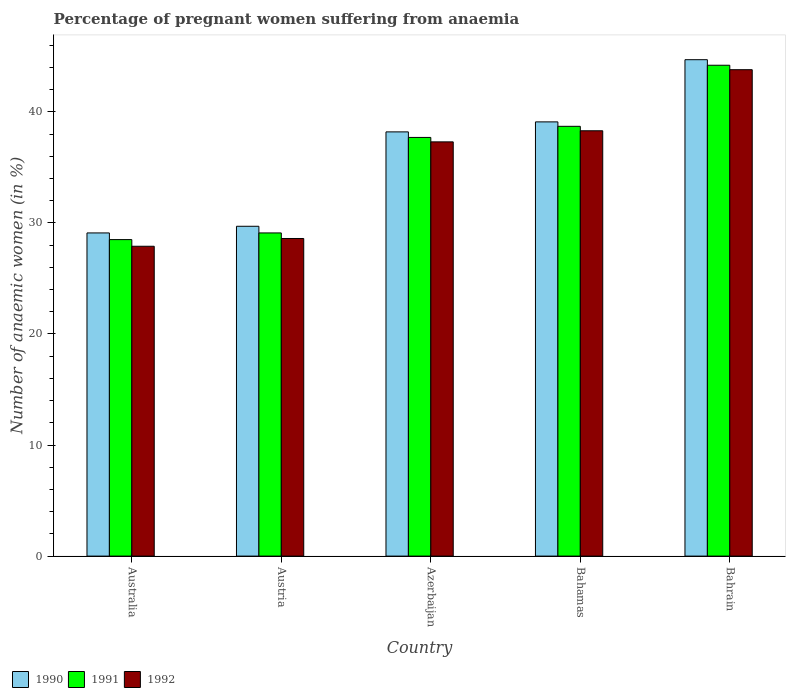How many different coloured bars are there?
Ensure brevity in your answer.  3. Are the number of bars per tick equal to the number of legend labels?
Provide a succinct answer. Yes. Are the number of bars on each tick of the X-axis equal?
Provide a short and direct response. Yes. What is the label of the 5th group of bars from the left?
Your answer should be compact. Bahrain. In how many cases, is the number of bars for a given country not equal to the number of legend labels?
Your answer should be compact. 0. What is the number of anaemic women in 1991 in Bahamas?
Your answer should be compact. 38.7. Across all countries, what is the maximum number of anaemic women in 1992?
Provide a short and direct response. 43.8. Across all countries, what is the minimum number of anaemic women in 1990?
Offer a very short reply. 29.1. In which country was the number of anaemic women in 1990 maximum?
Provide a succinct answer. Bahrain. In which country was the number of anaemic women in 1990 minimum?
Offer a very short reply. Australia. What is the total number of anaemic women in 1991 in the graph?
Provide a short and direct response. 178.2. What is the difference between the number of anaemic women in 1990 in Azerbaijan and that in Bahamas?
Offer a very short reply. -0.9. What is the average number of anaemic women in 1990 per country?
Provide a short and direct response. 36.16. What is the difference between the number of anaemic women of/in 1991 and number of anaemic women of/in 1992 in Australia?
Your answer should be compact. 0.6. In how many countries, is the number of anaemic women in 1991 greater than 28 %?
Give a very brief answer. 5. What is the ratio of the number of anaemic women in 1990 in Azerbaijan to that in Bahamas?
Make the answer very short. 0.98. Is the number of anaemic women in 1991 in Australia less than that in Bahamas?
Provide a succinct answer. Yes. What is the difference between the highest and the lowest number of anaemic women in 1991?
Give a very brief answer. 15.7. Is the sum of the number of anaemic women in 1990 in Australia and Azerbaijan greater than the maximum number of anaemic women in 1991 across all countries?
Offer a very short reply. Yes. What does the 3rd bar from the left in Australia represents?
Provide a short and direct response. 1992. Is it the case that in every country, the sum of the number of anaemic women in 1991 and number of anaemic women in 1990 is greater than the number of anaemic women in 1992?
Make the answer very short. Yes. How many bars are there?
Offer a very short reply. 15. How many countries are there in the graph?
Provide a succinct answer. 5. Where does the legend appear in the graph?
Provide a succinct answer. Bottom left. What is the title of the graph?
Keep it short and to the point. Percentage of pregnant women suffering from anaemia. What is the label or title of the X-axis?
Provide a succinct answer. Country. What is the label or title of the Y-axis?
Your answer should be compact. Number of anaemic women (in %). What is the Number of anaemic women (in %) of 1990 in Australia?
Give a very brief answer. 29.1. What is the Number of anaemic women (in %) of 1991 in Australia?
Your response must be concise. 28.5. What is the Number of anaemic women (in %) in 1992 in Australia?
Offer a terse response. 27.9. What is the Number of anaemic women (in %) of 1990 in Austria?
Ensure brevity in your answer.  29.7. What is the Number of anaemic women (in %) in 1991 in Austria?
Give a very brief answer. 29.1. What is the Number of anaemic women (in %) of 1992 in Austria?
Ensure brevity in your answer.  28.6. What is the Number of anaemic women (in %) in 1990 in Azerbaijan?
Your answer should be compact. 38.2. What is the Number of anaemic women (in %) in 1991 in Azerbaijan?
Ensure brevity in your answer.  37.7. What is the Number of anaemic women (in %) in 1992 in Azerbaijan?
Keep it short and to the point. 37.3. What is the Number of anaemic women (in %) in 1990 in Bahamas?
Your answer should be compact. 39.1. What is the Number of anaemic women (in %) of 1991 in Bahamas?
Your response must be concise. 38.7. What is the Number of anaemic women (in %) in 1992 in Bahamas?
Give a very brief answer. 38.3. What is the Number of anaemic women (in %) of 1990 in Bahrain?
Provide a succinct answer. 44.7. What is the Number of anaemic women (in %) of 1991 in Bahrain?
Your response must be concise. 44.2. What is the Number of anaemic women (in %) of 1992 in Bahrain?
Your answer should be compact. 43.8. Across all countries, what is the maximum Number of anaemic women (in %) of 1990?
Ensure brevity in your answer.  44.7. Across all countries, what is the maximum Number of anaemic women (in %) in 1991?
Your answer should be very brief. 44.2. Across all countries, what is the maximum Number of anaemic women (in %) of 1992?
Your answer should be compact. 43.8. Across all countries, what is the minimum Number of anaemic women (in %) in 1990?
Provide a short and direct response. 29.1. Across all countries, what is the minimum Number of anaemic women (in %) of 1991?
Make the answer very short. 28.5. Across all countries, what is the minimum Number of anaemic women (in %) in 1992?
Provide a short and direct response. 27.9. What is the total Number of anaemic women (in %) in 1990 in the graph?
Ensure brevity in your answer.  180.8. What is the total Number of anaemic women (in %) of 1991 in the graph?
Make the answer very short. 178.2. What is the total Number of anaemic women (in %) of 1992 in the graph?
Offer a very short reply. 175.9. What is the difference between the Number of anaemic women (in %) in 1990 in Australia and that in Austria?
Your answer should be compact. -0.6. What is the difference between the Number of anaemic women (in %) in 1991 in Australia and that in Austria?
Offer a very short reply. -0.6. What is the difference between the Number of anaemic women (in %) of 1992 in Australia and that in Austria?
Provide a succinct answer. -0.7. What is the difference between the Number of anaemic women (in %) of 1992 in Australia and that in Azerbaijan?
Your response must be concise. -9.4. What is the difference between the Number of anaemic women (in %) of 1990 in Australia and that in Bahrain?
Give a very brief answer. -15.6. What is the difference between the Number of anaemic women (in %) of 1991 in Australia and that in Bahrain?
Provide a short and direct response. -15.7. What is the difference between the Number of anaemic women (in %) of 1992 in Australia and that in Bahrain?
Offer a terse response. -15.9. What is the difference between the Number of anaemic women (in %) in 1991 in Austria and that in Azerbaijan?
Ensure brevity in your answer.  -8.6. What is the difference between the Number of anaemic women (in %) of 1992 in Austria and that in Bahamas?
Provide a succinct answer. -9.7. What is the difference between the Number of anaemic women (in %) of 1991 in Austria and that in Bahrain?
Offer a terse response. -15.1. What is the difference between the Number of anaemic women (in %) of 1992 in Austria and that in Bahrain?
Your response must be concise. -15.2. What is the difference between the Number of anaemic women (in %) of 1991 in Azerbaijan and that in Bahrain?
Offer a very short reply. -6.5. What is the difference between the Number of anaemic women (in %) of 1992 in Azerbaijan and that in Bahrain?
Provide a short and direct response. -6.5. What is the difference between the Number of anaemic women (in %) in 1990 in Bahamas and that in Bahrain?
Your answer should be very brief. -5.6. What is the difference between the Number of anaemic women (in %) of 1992 in Bahamas and that in Bahrain?
Your answer should be very brief. -5.5. What is the difference between the Number of anaemic women (in %) in 1990 in Australia and the Number of anaemic women (in %) in 1991 in Austria?
Provide a short and direct response. 0. What is the difference between the Number of anaemic women (in %) in 1990 in Australia and the Number of anaemic women (in %) in 1992 in Austria?
Provide a short and direct response. 0.5. What is the difference between the Number of anaemic women (in %) of 1991 in Australia and the Number of anaemic women (in %) of 1992 in Austria?
Your answer should be compact. -0.1. What is the difference between the Number of anaemic women (in %) in 1990 in Australia and the Number of anaemic women (in %) in 1992 in Azerbaijan?
Make the answer very short. -8.2. What is the difference between the Number of anaemic women (in %) in 1991 in Australia and the Number of anaemic women (in %) in 1992 in Azerbaijan?
Your response must be concise. -8.8. What is the difference between the Number of anaemic women (in %) in 1991 in Australia and the Number of anaemic women (in %) in 1992 in Bahamas?
Give a very brief answer. -9.8. What is the difference between the Number of anaemic women (in %) in 1990 in Australia and the Number of anaemic women (in %) in 1991 in Bahrain?
Your answer should be compact. -15.1. What is the difference between the Number of anaemic women (in %) in 1990 in Australia and the Number of anaemic women (in %) in 1992 in Bahrain?
Provide a succinct answer. -14.7. What is the difference between the Number of anaemic women (in %) of 1991 in Australia and the Number of anaemic women (in %) of 1992 in Bahrain?
Ensure brevity in your answer.  -15.3. What is the difference between the Number of anaemic women (in %) of 1990 in Austria and the Number of anaemic women (in %) of 1991 in Azerbaijan?
Make the answer very short. -8. What is the difference between the Number of anaemic women (in %) of 1990 in Austria and the Number of anaemic women (in %) of 1992 in Bahamas?
Ensure brevity in your answer.  -8.6. What is the difference between the Number of anaemic women (in %) of 1990 in Austria and the Number of anaemic women (in %) of 1991 in Bahrain?
Make the answer very short. -14.5. What is the difference between the Number of anaemic women (in %) of 1990 in Austria and the Number of anaemic women (in %) of 1992 in Bahrain?
Provide a short and direct response. -14.1. What is the difference between the Number of anaemic women (in %) in 1991 in Austria and the Number of anaemic women (in %) in 1992 in Bahrain?
Keep it short and to the point. -14.7. What is the difference between the Number of anaemic women (in %) of 1991 in Azerbaijan and the Number of anaemic women (in %) of 1992 in Bahamas?
Offer a terse response. -0.6. What is the difference between the Number of anaemic women (in %) in 1990 in Azerbaijan and the Number of anaemic women (in %) in 1991 in Bahrain?
Your answer should be compact. -6. What is the difference between the Number of anaemic women (in %) in 1991 in Azerbaijan and the Number of anaemic women (in %) in 1992 in Bahrain?
Ensure brevity in your answer.  -6.1. What is the difference between the Number of anaemic women (in %) of 1990 in Bahamas and the Number of anaemic women (in %) of 1992 in Bahrain?
Offer a very short reply. -4.7. What is the average Number of anaemic women (in %) of 1990 per country?
Your answer should be very brief. 36.16. What is the average Number of anaemic women (in %) of 1991 per country?
Offer a terse response. 35.64. What is the average Number of anaemic women (in %) in 1992 per country?
Your response must be concise. 35.18. What is the difference between the Number of anaemic women (in %) in 1990 and Number of anaemic women (in %) in 1991 in Australia?
Make the answer very short. 0.6. What is the difference between the Number of anaemic women (in %) in 1991 and Number of anaemic women (in %) in 1992 in Australia?
Keep it short and to the point. 0.6. What is the difference between the Number of anaemic women (in %) in 1990 and Number of anaemic women (in %) in 1991 in Austria?
Your response must be concise. 0.6. What is the difference between the Number of anaemic women (in %) of 1990 and Number of anaemic women (in %) of 1992 in Austria?
Offer a very short reply. 1.1. What is the difference between the Number of anaemic women (in %) in 1990 and Number of anaemic women (in %) in 1991 in Azerbaijan?
Your answer should be very brief. 0.5. What is the difference between the Number of anaemic women (in %) of 1991 and Number of anaemic women (in %) of 1992 in Azerbaijan?
Keep it short and to the point. 0.4. What is the difference between the Number of anaemic women (in %) of 1990 and Number of anaemic women (in %) of 1991 in Bahamas?
Keep it short and to the point. 0.4. What is the difference between the Number of anaemic women (in %) in 1990 and Number of anaemic women (in %) in 1992 in Bahamas?
Keep it short and to the point. 0.8. What is the difference between the Number of anaemic women (in %) in 1991 and Number of anaemic women (in %) in 1992 in Bahamas?
Provide a succinct answer. 0.4. What is the difference between the Number of anaemic women (in %) of 1990 and Number of anaemic women (in %) of 1991 in Bahrain?
Make the answer very short. 0.5. What is the ratio of the Number of anaemic women (in %) of 1990 in Australia to that in Austria?
Your answer should be very brief. 0.98. What is the ratio of the Number of anaemic women (in %) of 1991 in Australia to that in Austria?
Your answer should be compact. 0.98. What is the ratio of the Number of anaemic women (in %) of 1992 in Australia to that in Austria?
Provide a succinct answer. 0.98. What is the ratio of the Number of anaemic women (in %) in 1990 in Australia to that in Azerbaijan?
Offer a terse response. 0.76. What is the ratio of the Number of anaemic women (in %) in 1991 in Australia to that in Azerbaijan?
Offer a terse response. 0.76. What is the ratio of the Number of anaemic women (in %) in 1992 in Australia to that in Azerbaijan?
Offer a very short reply. 0.75. What is the ratio of the Number of anaemic women (in %) in 1990 in Australia to that in Bahamas?
Your answer should be very brief. 0.74. What is the ratio of the Number of anaemic women (in %) of 1991 in Australia to that in Bahamas?
Your response must be concise. 0.74. What is the ratio of the Number of anaemic women (in %) of 1992 in Australia to that in Bahamas?
Provide a short and direct response. 0.73. What is the ratio of the Number of anaemic women (in %) in 1990 in Australia to that in Bahrain?
Offer a very short reply. 0.65. What is the ratio of the Number of anaemic women (in %) in 1991 in Australia to that in Bahrain?
Your answer should be compact. 0.64. What is the ratio of the Number of anaemic women (in %) of 1992 in Australia to that in Bahrain?
Give a very brief answer. 0.64. What is the ratio of the Number of anaemic women (in %) in 1990 in Austria to that in Azerbaijan?
Ensure brevity in your answer.  0.78. What is the ratio of the Number of anaemic women (in %) in 1991 in Austria to that in Azerbaijan?
Make the answer very short. 0.77. What is the ratio of the Number of anaemic women (in %) in 1992 in Austria to that in Azerbaijan?
Offer a terse response. 0.77. What is the ratio of the Number of anaemic women (in %) of 1990 in Austria to that in Bahamas?
Your answer should be very brief. 0.76. What is the ratio of the Number of anaemic women (in %) of 1991 in Austria to that in Bahamas?
Your answer should be very brief. 0.75. What is the ratio of the Number of anaemic women (in %) of 1992 in Austria to that in Bahamas?
Offer a terse response. 0.75. What is the ratio of the Number of anaemic women (in %) of 1990 in Austria to that in Bahrain?
Offer a very short reply. 0.66. What is the ratio of the Number of anaemic women (in %) in 1991 in Austria to that in Bahrain?
Your response must be concise. 0.66. What is the ratio of the Number of anaemic women (in %) in 1992 in Austria to that in Bahrain?
Your answer should be compact. 0.65. What is the ratio of the Number of anaemic women (in %) in 1990 in Azerbaijan to that in Bahamas?
Provide a succinct answer. 0.98. What is the ratio of the Number of anaemic women (in %) of 1991 in Azerbaijan to that in Bahamas?
Keep it short and to the point. 0.97. What is the ratio of the Number of anaemic women (in %) in 1992 in Azerbaijan to that in Bahamas?
Keep it short and to the point. 0.97. What is the ratio of the Number of anaemic women (in %) in 1990 in Azerbaijan to that in Bahrain?
Your answer should be very brief. 0.85. What is the ratio of the Number of anaemic women (in %) in 1991 in Azerbaijan to that in Bahrain?
Give a very brief answer. 0.85. What is the ratio of the Number of anaemic women (in %) in 1992 in Azerbaijan to that in Bahrain?
Your response must be concise. 0.85. What is the ratio of the Number of anaemic women (in %) in 1990 in Bahamas to that in Bahrain?
Your answer should be compact. 0.87. What is the ratio of the Number of anaemic women (in %) of 1991 in Bahamas to that in Bahrain?
Your response must be concise. 0.88. What is the ratio of the Number of anaemic women (in %) of 1992 in Bahamas to that in Bahrain?
Offer a terse response. 0.87. What is the difference between the highest and the lowest Number of anaemic women (in %) of 1992?
Your response must be concise. 15.9. 